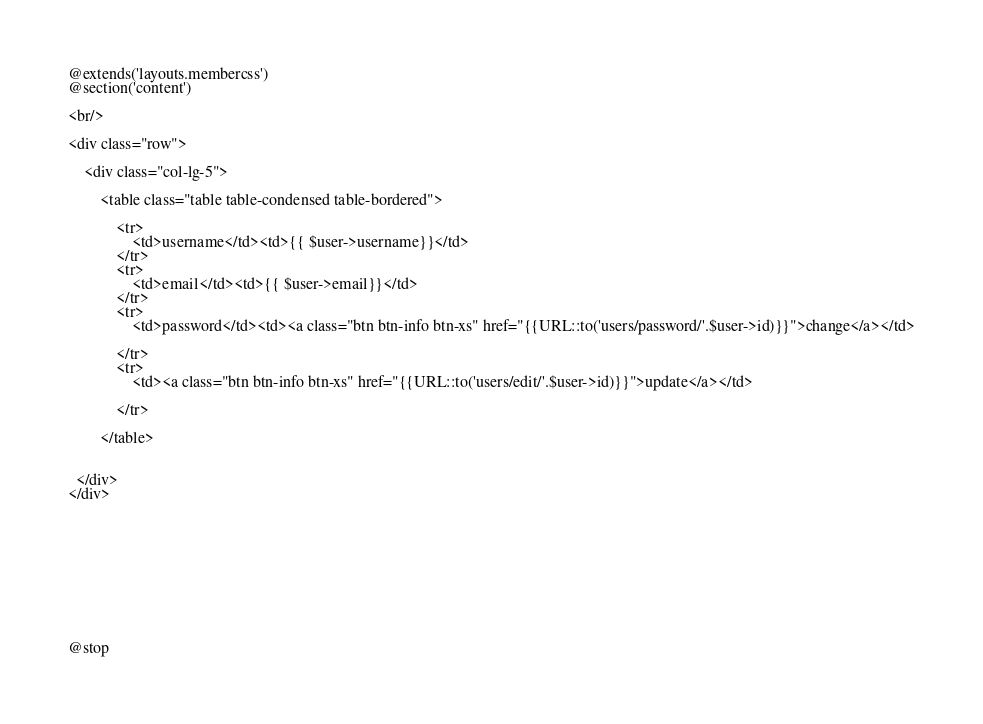<code> <loc_0><loc_0><loc_500><loc_500><_PHP_>@extends('layouts.membercss')
@section('content')

<br/>

<div class="row">

	<div class="col-lg-5">

		<table class="table table-condensed table-bordered">

            <tr>
                <td>username</td><td>{{ $user->username}}</td>
            </tr>
            <tr>
                <td>email</td><td>{{ $user->email}}</td>
            </tr>
            <tr>
                <td>password</td><td><a class="btn btn-info btn-xs" href="{{URL::to('users/password/'.$user->id)}}">change</a></td>

            </tr>
            <tr>
                <td><a class="btn btn-info btn-xs" href="{{URL::to('users/edit/'.$user->id)}}">update</a></td>

            </tr>

        </table>
		

  </div>
</div>










@stop</code> 